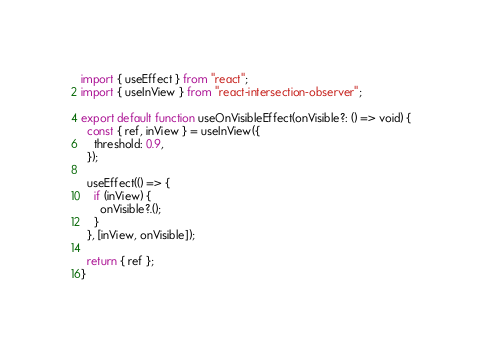<code> <loc_0><loc_0><loc_500><loc_500><_TypeScript_>import { useEffect } from "react";
import { useInView } from "react-intersection-observer";

export default function useOnVisibleEffect(onVisible?: () => void) {
  const { ref, inView } = useInView({
    threshold: 0.9,
  });

  useEffect(() => {
    if (inView) {
      onVisible?.();
    }
  }, [inView, onVisible]);

  return { ref };
}
</code> 